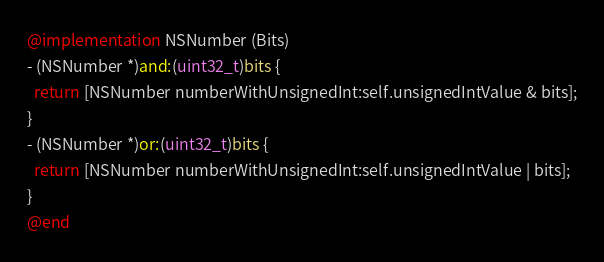Convert code to text. <code><loc_0><loc_0><loc_500><loc_500><_ObjectiveC_>
@implementation NSNumber (Bits)
- (NSNumber *)and:(uint32_t)bits {
  return [NSNumber numberWithUnsignedInt:self.unsignedIntValue & bits];
}
- (NSNumber *)or:(uint32_t)bits {
  return [NSNumber numberWithUnsignedInt:self.unsignedIntValue | bits];
}
@end
</code> 